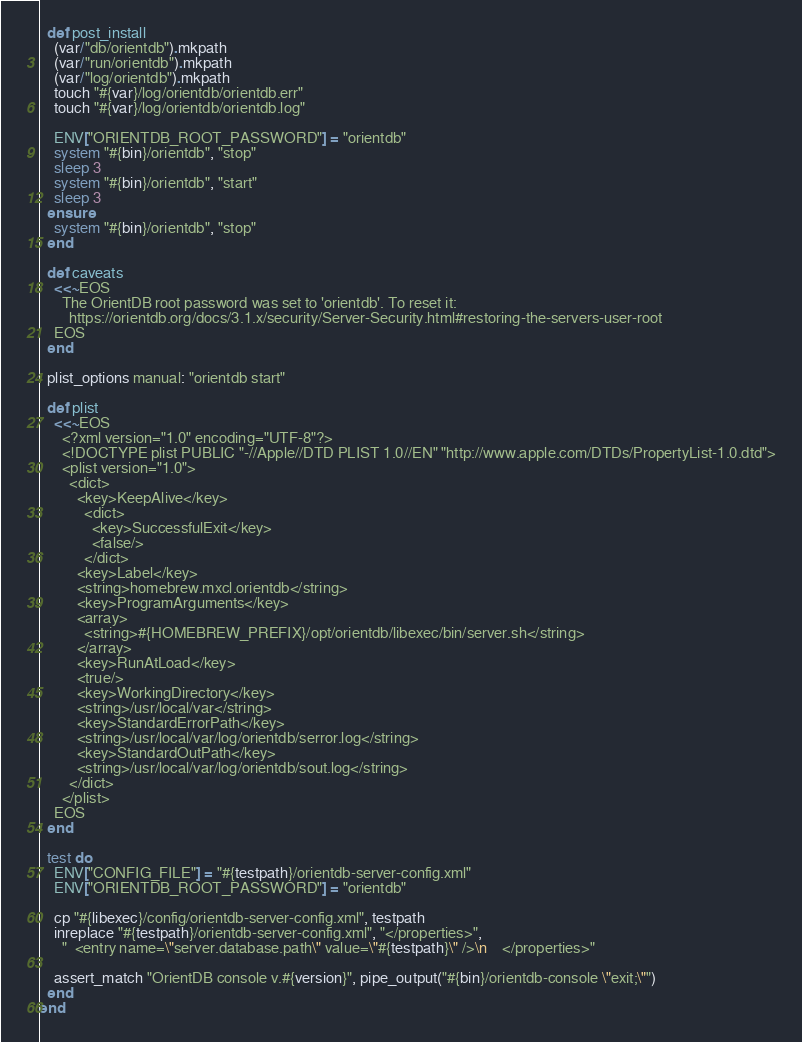<code> <loc_0><loc_0><loc_500><loc_500><_Ruby_>
  def post_install
    (var/"db/orientdb").mkpath
    (var/"run/orientdb").mkpath
    (var/"log/orientdb").mkpath
    touch "#{var}/log/orientdb/orientdb.err"
    touch "#{var}/log/orientdb/orientdb.log"

    ENV["ORIENTDB_ROOT_PASSWORD"] = "orientdb"
    system "#{bin}/orientdb", "stop"
    sleep 3
    system "#{bin}/orientdb", "start"
    sleep 3
  ensure
    system "#{bin}/orientdb", "stop"
  end

  def caveats
    <<~EOS
      The OrientDB root password was set to 'orientdb'. To reset it:
        https://orientdb.org/docs/3.1.x/security/Server-Security.html#restoring-the-servers-user-root
    EOS
  end

  plist_options manual: "orientdb start"

  def plist
    <<~EOS
      <?xml version="1.0" encoding="UTF-8"?>
      <!DOCTYPE plist PUBLIC "-//Apple//DTD PLIST 1.0//EN" "http://www.apple.com/DTDs/PropertyList-1.0.dtd">
      <plist version="1.0">
        <dict>
          <key>KeepAlive</key>
            <dict>
              <key>SuccessfulExit</key>
              <false/>
            </dict>
          <key>Label</key>
          <string>homebrew.mxcl.orientdb</string>
          <key>ProgramArguments</key>
          <array>
            <string>#{HOMEBREW_PREFIX}/opt/orientdb/libexec/bin/server.sh</string>
          </array>
          <key>RunAtLoad</key>
          <true/>
          <key>WorkingDirectory</key>
          <string>/usr/local/var</string>
          <key>StandardErrorPath</key>
          <string>/usr/local/var/log/orientdb/serror.log</string>
          <key>StandardOutPath</key>
          <string>/usr/local/var/log/orientdb/sout.log</string>
        </dict>
      </plist>
    EOS
  end

  test do
    ENV["CONFIG_FILE"] = "#{testpath}/orientdb-server-config.xml"
    ENV["ORIENTDB_ROOT_PASSWORD"] = "orientdb"

    cp "#{libexec}/config/orientdb-server-config.xml", testpath
    inreplace "#{testpath}/orientdb-server-config.xml", "</properties>",
      "  <entry name=\"server.database.path\" value=\"#{testpath}\" />\n    </properties>"

    assert_match "OrientDB console v.#{version}", pipe_output("#{bin}/orientdb-console \"exit;\"")
  end
end
</code> 